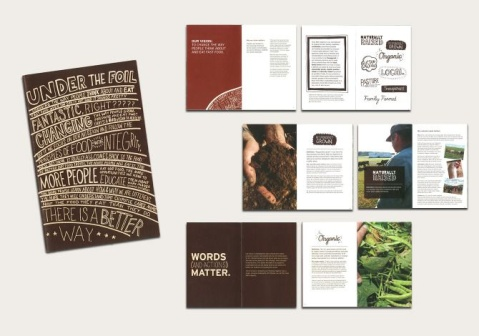What significance do the images of food and plants have in these printed materials? The images of food and plants on these printed materials play a crucial role in visually communicating their themes. Likely tied to messages about organic farming, locally sourced produce, or the benefits of a natural lifestyle, these images help to cement the material’s messaging about healthier, more sustainable living practices. They also add an aesthetic appeal that aligns with the materials’ environmental themes, making the information more relatable and compelling to the audience. 